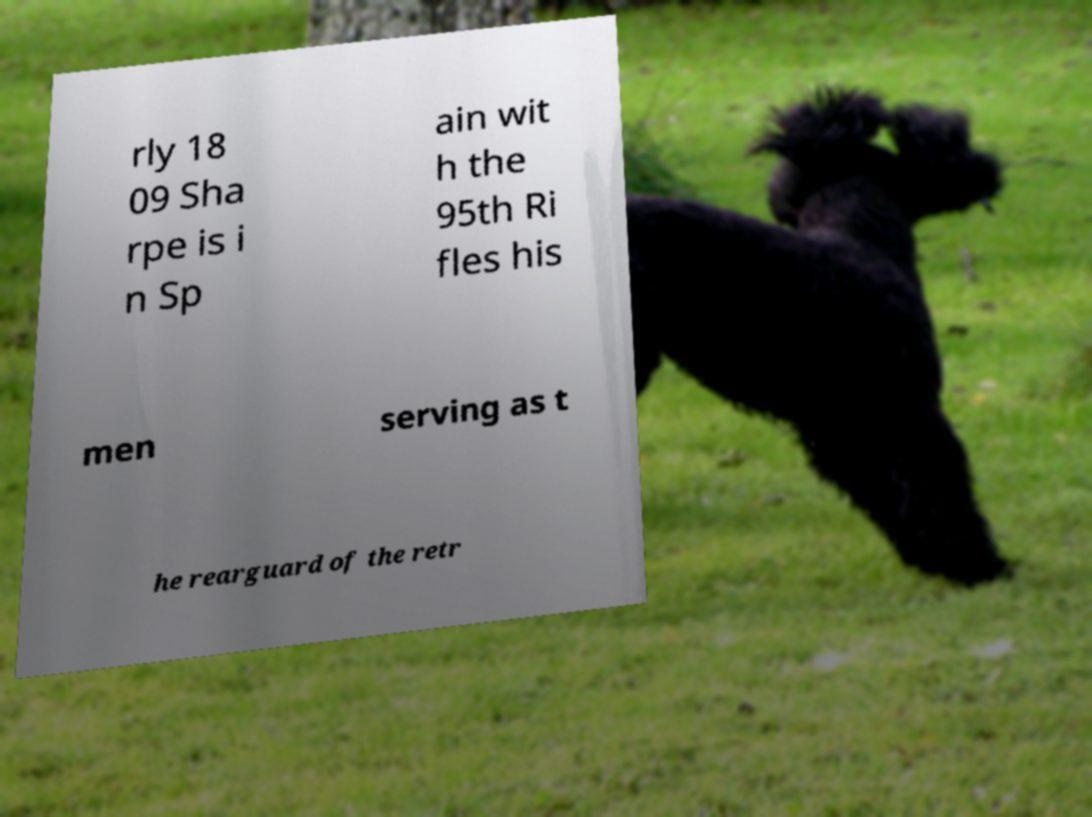Could you assist in decoding the text presented in this image and type it out clearly? rly 18 09 Sha rpe is i n Sp ain wit h the 95th Ri fles his men serving as t he rearguard of the retr 